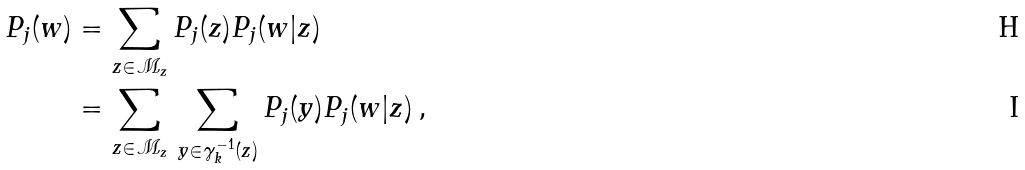<formula> <loc_0><loc_0><loc_500><loc_500>P _ { j } ( w ) & = \sum _ { z \in \mathcal { M } _ { z } } P _ { j } ( z ) P _ { j } ( w | z ) \\ & = \sum _ { z \in \mathcal { M } _ { z } } \, \sum _ { y \in \gamma _ { k } ^ { - 1 } ( z ) } P _ { j } ( y ) P _ { j } ( w | z ) \, ,</formula> 